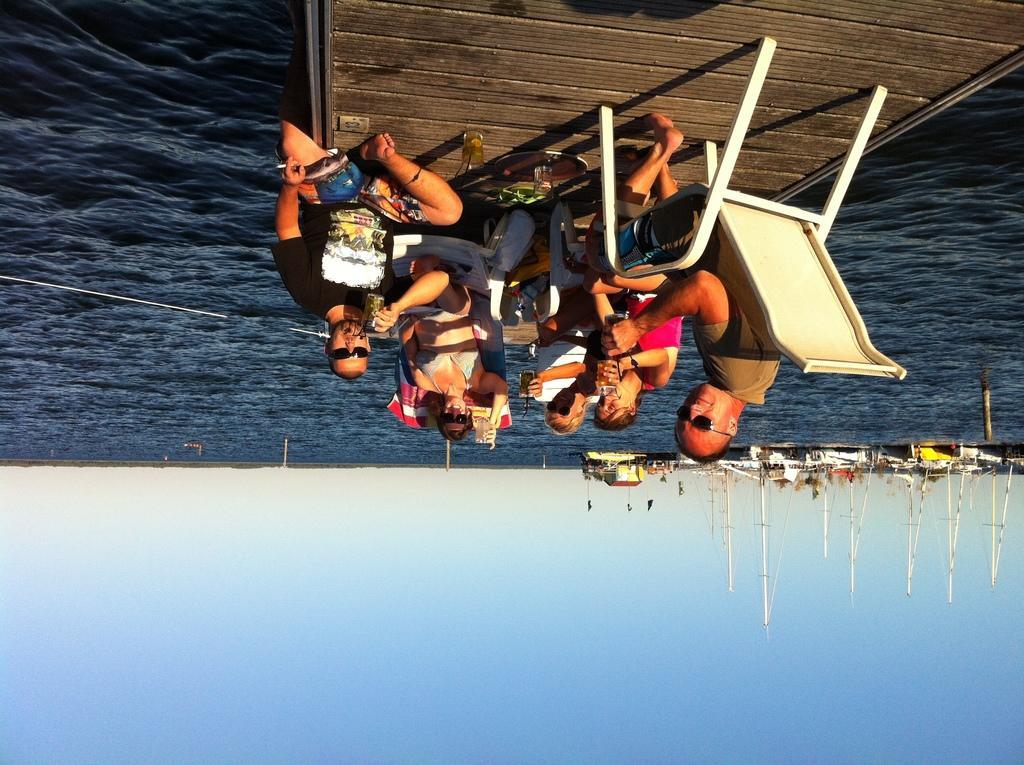In one or two sentences, can you explain what this image depicts? In this picture I can see there is a wooden bridge, there are a few people sitting on the chairs and there are boats sailing on the water at the right side. The sky is clear. 